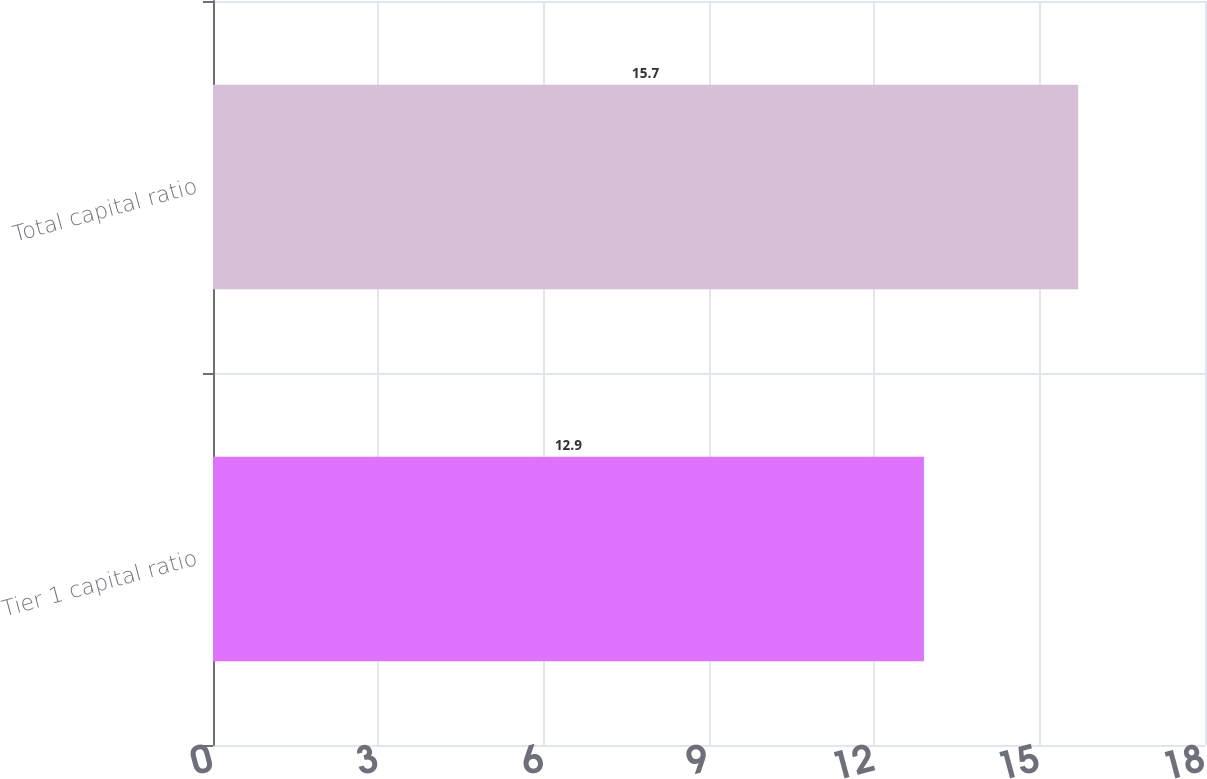<chart> <loc_0><loc_0><loc_500><loc_500><bar_chart><fcel>Tier 1 capital ratio<fcel>Total capital ratio<nl><fcel>12.9<fcel>15.7<nl></chart> 